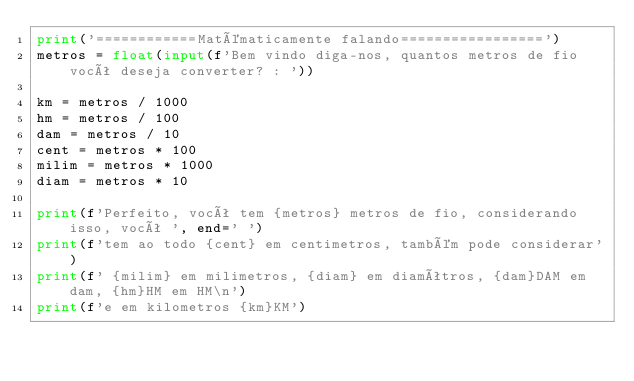<code> <loc_0><loc_0><loc_500><loc_500><_Python_>print('============Matématicamente falando=================')
metros = float(input(f'Bem vindo diga-nos, quantos metros de fio você deseja converter? : '))

km = metros / 1000
hm = metros / 100
dam = metros / 10
cent = metros * 100
milim = metros * 1000
diam = metros * 10

print(f'Perfeito, você tem {metros} metros de fio, considerando isso, você ', end=' ')
print(f'tem ao todo {cent} em centimetros, também pode considerar')
print(f' {milim} em milimetros, {diam} em diamêtros, {dam}DAM em dam, {hm}HM em HM\n')
print(f'e em kilometros {km}KM')

</code> 